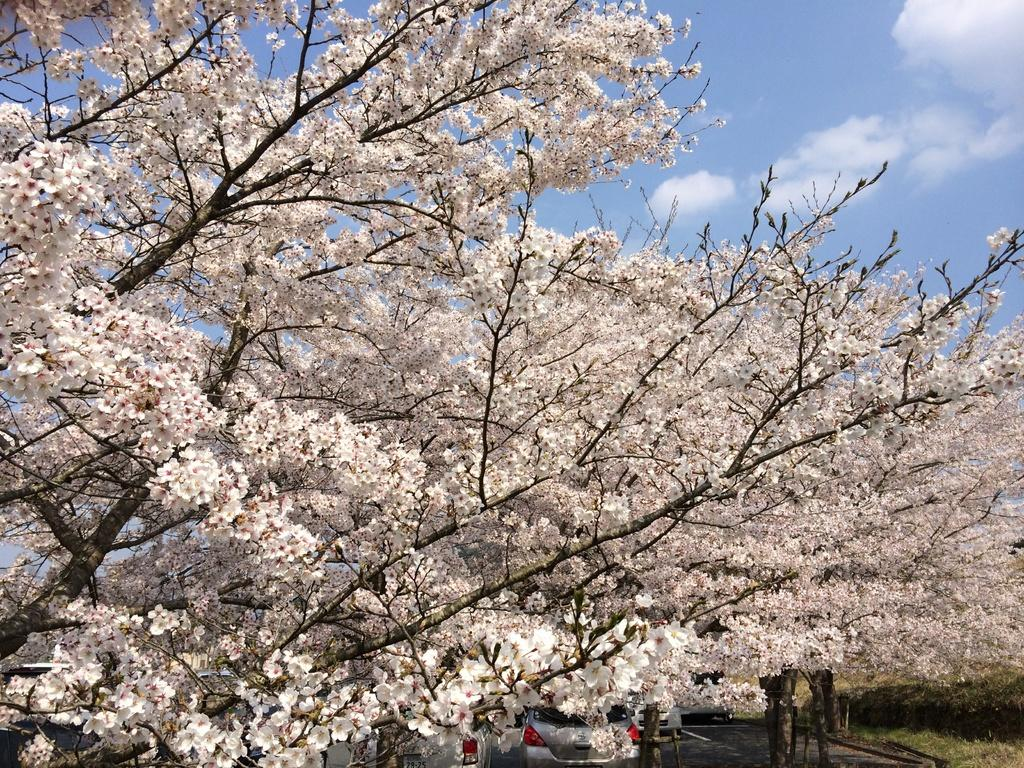What type of vegetation can be seen in the image? There are trees, flowers, and grass in the image. What else is present in the image besides vegetation? There are cars in the image. What can be seen in the background of the image? The sky is visible in the background of the image, and there are clouds in the sky. What knowledge is being shared during the battle in the image? There is no battle present in the image; it features trees, flowers, grass, cars, and a sky with clouds. How many times does the person sneeze in the image? There is no person sneezing in the image. 